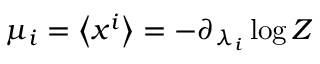Convert formula to latex. <formula><loc_0><loc_0><loc_500><loc_500>\mu _ { i } = \left \langle x ^ { i } \right \rangle = - \partial _ { \lambda _ { i } } \log Z</formula> 